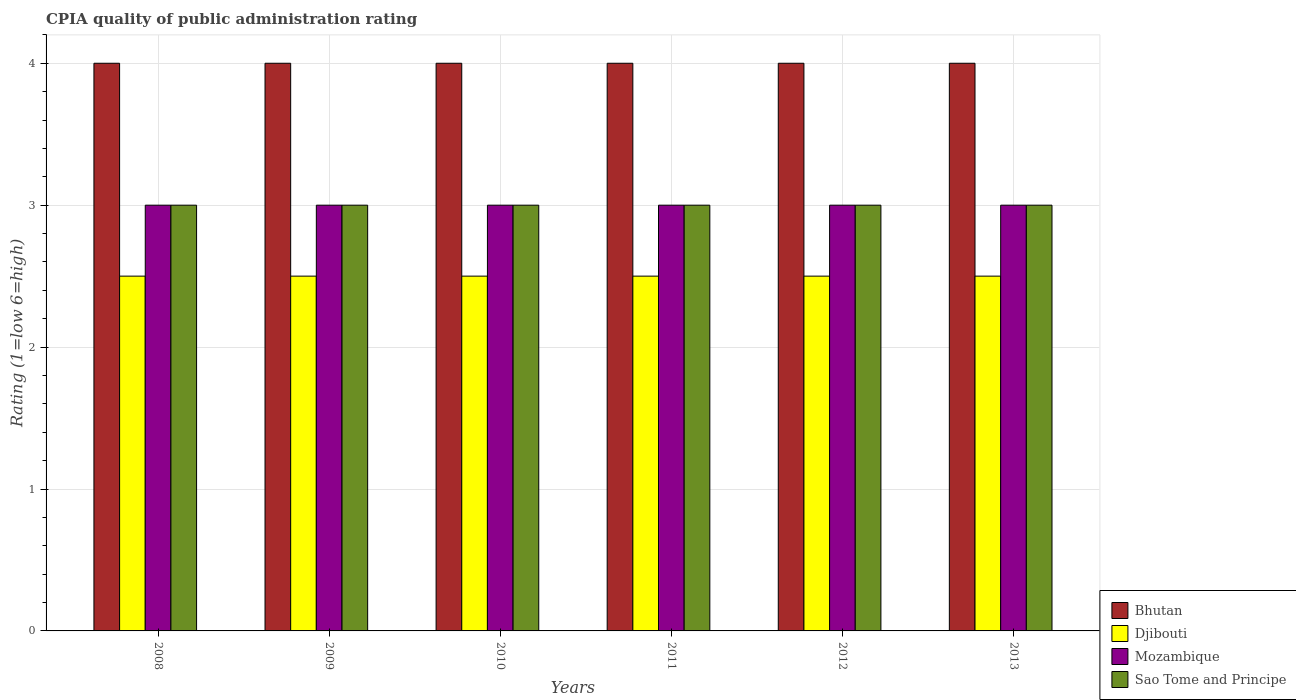How many different coloured bars are there?
Your answer should be compact. 4. How many bars are there on the 6th tick from the right?
Provide a short and direct response. 4. What is the label of the 4th group of bars from the left?
Ensure brevity in your answer.  2011. In how many cases, is the number of bars for a given year not equal to the number of legend labels?
Your answer should be compact. 0. Across all years, what is the maximum CPIA rating in Bhutan?
Give a very brief answer. 4. Across all years, what is the minimum CPIA rating in Mozambique?
Your answer should be compact. 3. What is the total CPIA rating in Bhutan in the graph?
Your response must be concise. 24. What is the difference between the CPIA rating in Bhutan in 2009 and that in 2011?
Ensure brevity in your answer.  0. What is the difference between the CPIA rating in Sao Tome and Principe in 2008 and the CPIA rating in Djibouti in 2013?
Your response must be concise. 0.5. Is the difference between the CPIA rating in Bhutan in 2008 and 2013 greater than the difference between the CPIA rating in Mozambique in 2008 and 2013?
Ensure brevity in your answer.  No. What is the difference between the highest and the lowest CPIA rating in Djibouti?
Provide a succinct answer. 0. In how many years, is the CPIA rating in Djibouti greater than the average CPIA rating in Djibouti taken over all years?
Offer a terse response. 0. What does the 4th bar from the left in 2013 represents?
Your answer should be compact. Sao Tome and Principe. What does the 2nd bar from the right in 2011 represents?
Ensure brevity in your answer.  Mozambique. Is it the case that in every year, the sum of the CPIA rating in Sao Tome and Principe and CPIA rating in Mozambique is greater than the CPIA rating in Djibouti?
Your answer should be compact. Yes. How many bars are there?
Your answer should be very brief. 24. Are all the bars in the graph horizontal?
Ensure brevity in your answer.  No. How many years are there in the graph?
Your answer should be compact. 6. What is the difference between two consecutive major ticks on the Y-axis?
Keep it short and to the point. 1. Are the values on the major ticks of Y-axis written in scientific E-notation?
Your response must be concise. No. Does the graph contain any zero values?
Make the answer very short. No. What is the title of the graph?
Give a very brief answer. CPIA quality of public administration rating. What is the label or title of the X-axis?
Provide a succinct answer. Years. What is the Rating (1=low 6=high) in Bhutan in 2008?
Your answer should be compact. 4. What is the Rating (1=low 6=high) in Djibouti in 2008?
Ensure brevity in your answer.  2.5. What is the Rating (1=low 6=high) of Sao Tome and Principe in 2008?
Provide a short and direct response. 3. What is the Rating (1=low 6=high) of Bhutan in 2009?
Provide a succinct answer. 4. What is the Rating (1=low 6=high) in Mozambique in 2009?
Provide a short and direct response. 3. What is the Rating (1=low 6=high) in Sao Tome and Principe in 2009?
Keep it short and to the point. 3. What is the Rating (1=low 6=high) of Sao Tome and Principe in 2010?
Your response must be concise. 3. What is the Rating (1=low 6=high) of Bhutan in 2011?
Give a very brief answer. 4. What is the Rating (1=low 6=high) of Mozambique in 2011?
Ensure brevity in your answer.  3. What is the Rating (1=low 6=high) in Sao Tome and Principe in 2011?
Give a very brief answer. 3. What is the Rating (1=low 6=high) in Sao Tome and Principe in 2012?
Ensure brevity in your answer.  3. What is the Rating (1=low 6=high) of Bhutan in 2013?
Your response must be concise. 4. What is the Rating (1=low 6=high) of Djibouti in 2013?
Give a very brief answer. 2.5. What is the Rating (1=low 6=high) of Mozambique in 2013?
Provide a short and direct response. 3. What is the Rating (1=low 6=high) of Sao Tome and Principe in 2013?
Your response must be concise. 3. Across all years, what is the maximum Rating (1=low 6=high) of Bhutan?
Offer a very short reply. 4. Across all years, what is the maximum Rating (1=low 6=high) in Sao Tome and Principe?
Ensure brevity in your answer.  3. Across all years, what is the minimum Rating (1=low 6=high) in Djibouti?
Make the answer very short. 2.5. Across all years, what is the minimum Rating (1=low 6=high) of Sao Tome and Principe?
Give a very brief answer. 3. What is the total Rating (1=low 6=high) in Bhutan in the graph?
Provide a short and direct response. 24. What is the total Rating (1=low 6=high) of Djibouti in the graph?
Provide a short and direct response. 15. What is the difference between the Rating (1=low 6=high) of Bhutan in 2008 and that in 2009?
Your answer should be compact. 0. What is the difference between the Rating (1=low 6=high) in Djibouti in 2008 and that in 2009?
Ensure brevity in your answer.  0. What is the difference between the Rating (1=low 6=high) of Mozambique in 2008 and that in 2009?
Offer a terse response. 0. What is the difference between the Rating (1=low 6=high) of Sao Tome and Principe in 2008 and that in 2010?
Give a very brief answer. 0. What is the difference between the Rating (1=low 6=high) of Sao Tome and Principe in 2008 and that in 2011?
Your response must be concise. 0. What is the difference between the Rating (1=low 6=high) in Djibouti in 2008 and that in 2012?
Offer a terse response. 0. What is the difference between the Rating (1=low 6=high) in Bhutan in 2008 and that in 2013?
Offer a terse response. 0. What is the difference between the Rating (1=low 6=high) of Djibouti in 2008 and that in 2013?
Provide a succinct answer. 0. What is the difference between the Rating (1=low 6=high) in Sao Tome and Principe in 2009 and that in 2010?
Keep it short and to the point. 0. What is the difference between the Rating (1=low 6=high) in Bhutan in 2009 and that in 2011?
Offer a very short reply. 0. What is the difference between the Rating (1=low 6=high) of Sao Tome and Principe in 2009 and that in 2011?
Your answer should be very brief. 0. What is the difference between the Rating (1=low 6=high) of Mozambique in 2009 and that in 2012?
Your response must be concise. 0. What is the difference between the Rating (1=low 6=high) in Sao Tome and Principe in 2009 and that in 2012?
Your answer should be very brief. 0. What is the difference between the Rating (1=low 6=high) of Bhutan in 2009 and that in 2013?
Your answer should be very brief. 0. What is the difference between the Rating (1=low 6=high) in Djibouti in 2009 and that in 2013?
Keep it short and to the point. 0. What is the difference between the Rating (1=low 6=high) of Mozambique in 2009 and that in 2013?
Offer a very short reply. 0. What is the difference between the Rating (1=low 6=high) in Sao Tome and Principe in 2009 and that in 2013?
Ensure brevity in your answer.  0. What is the difference between the Rating (1=low 6=high) of Bhutan in 2010 and that in 2011?
Keep it short and to the point. 0. What is the difference between the Rating (1=low 6=high) in Djibouti in 2010 and that in 2011?
Provide a succinct answer. 0. What is the difference between the Rating (1=low 6=high) of Mozambique in 2010 and that in 2011?
Provide a short and direct response. 0. What is the difference between the Rating (1=low 6=high) of Bhutan in 2010 and that in 2012?
Make the answer very short. 0. What is the difference between the Rating (1=low 6=high) of Djibouti in 2010 and that in 2012?
Make the answer very short. 0. What is the difference between the Rating (1=low 6=high) in Mozambique in 2010 and that in 2012?
Offer a terse response. 0. What is the difference between the Rating (1=low 6=high) of Sao Tome and Principe in 2010 and that in 2012?
Ensure brevity in your answer.  0. What is the difference between the Rating (1=low 6=high) in Mozambique in 2010 and that in 2013?
Give a very brief answer. 0. What is the difference between the Rating (1=low 6=high) in Djibouti in 2011 and that in 2012?
Make the answer very short. 0. What is the difference between the Rating (1=low 6=high) of Mozambique in 2011 and that in 2012?
Your answer should be compact. 0. What is the difference between the Rating (1=low 6=high) in Bhutan in 2011 and that in 2013?
Your answer should be compact. 0. What is the difference between the Rating (1=low 6=high) of Mozambique in 2011 and that in 2013?
Offer a very short reply. 0. What is the difference between the Rating (1=low 6=high) of Bhutan in 2012 and that in 2013?
Keep it short and to the point. 0. What is the difference between the Rating (1=low 6=high) of Djibouti in 2012 and that in 2013?
Your answer should be very brief. 0. What is the difference between the Rating (1=low 6=high) of Mozambique in 2012 and that in 2013?
Offer a very short reply. 0. What is the difference between the Rating (1=low 6=high) of Bhutan in 2008 and the Rating (1=low 6=high) of Djibouti in 2009?
Your answer should be compact. 1.5. What is the difference between the Rating (1=low 6=high) in Bhutan in 2008 and the Rating (1=low 6=high) in Mozambique in 2009?
Your response must be concise. 1. What is the difference between the Rating (1=low 6=high) in Bhutan in 2008 and the Rating (1=low 6=high) in Sao Tome and Principe in 2010?
Your response must be concise. 1. What is the difference between the Rating (1=low 6=high) of Bhutan in 2008 and the Rating (1=low 6=high) of Djibouti in 2011?
Provide a succinct answer. 1.5. What is the difference between the Rating (1=low 6=high) in Bhutan in 2008 and the Rating (1=low 6=high) in Sao Tome and Principe in 2011?
Provide a succinct answer. 1. What is the difference between the Rating (1=low 6=high) in Djibouti in 2008 and the Rating (1=low 6=high) in Mozambique in 2011?
Offer a terse response. -0.5. What is the difference between the Rating (1=low 6=high) in Djibouti in 2008 and the Rating (1=low 6=high) in Sao Tome and Principe in 2011?
Provide a succinct answer. -0.5. What is the difference between the Rating (1=low 6=high) in Bhutan in 2008 and the Rating (1=low 6=high) in Mozambique in 2012?
Your answer should be compact. 1. What is the difference between the Rating (1=low 6=high) of Bhutan in 2008 and the Rating (1=low 6=high) of Sao Tome and Principe in 2012?
Ensure brevity in your answer.  1. What is the difference between the Rating (1=low 6=high) in Djibouti in 2008 and the Rating (1=low 6=high) in Mozambique in 2012?
Provide a succinct answer. -0.5. What is the difference between the Rating (1=low 6=high) in Djibouti in 2008 and the Rating (1=low 6=high) in Sao Tome and Principe in 2012?
Offer a terse response. -0.5. What is the difference between the Rating (1=low 6=high) of Mozambique in 2008 and the Rating (1=low 6=high) of Sao Tome and Principe in 2012?
Offer a very short reply. 0. What is the difference between the Rating (1=low 6=high) of Bhutan in 2008 and the Rating (1=low 6=high) of Mozambique in 2013?
Offer a terse response. 1. What is the difference between the Rating (1=low 6=high) in Bhutan in 2008 and the Rating (1=low 6=high) in Sao Tome and Principe in 2013?
Offer a terse response. 1. What is the difference between the Rating (1=low 6=high) in Mozambique in 2008 and the Rating (1=low 6=high) in Sao Tome and Principe in 2013?
Give a very brief answer. 0. What is the difference between the Rating (1=low 6=high) in Djibouti in 2009 and the Rating (1=low 6=high) in Sao Tome and Principe in 2010?
Your response must be concise. -0.5. What is the difference between the Rating (1=low 6=high) of Mozambique in 2009 and the Rating (1=low 6=high) of Sao Tome and Principe in 2010?
Your response must be concise. 0. What is the difference between the Rating (1=low 6=high) in Bhutan in 2009 and the Rating (1=low 6=high) in Mozambique in 2011?
Offer a terse response. 1. What is the difference between the Rating (1=low 6=high) in Bhutan in 2009 and the Rating (1=low 6=high) in Sao Tome and Principe in 2011?
Provide a succinct answer. 1. What is the difference between the Rating (1=low 6=high) of Djibouti in 2009 and the Rating (1=low 6=high) of Sao Tome and Principe in 2011?
Offer a very short reply. -0.5. What is the difference between the Rating (1=low 6=high) in Mozambique in 2009 and the Rating (1=low 6=high) in Sao Tome and Principe in 2011?
Give a very brief answer. 0. What is the difference between the Rating (1=low 6=high) in Bhutan in 2009 and the Rating (1=low 6=high) in Djibouti in 2012?
Provide a short and direct response. 1.5. What is the difference between the Rating (1=low 6=high) in Bhutan in 2009 and the Rating (1=low 6=high) in Mozambique in 2012?
Provide a short and direct response. 1. What is the difference between the Rating (1=low 6=high) in Djibouti in 2009 and the Rating (1=low 6=high) in Mozambique in 2012?
Ensure brevity in your answer.  -0.5. What is the difference between the Rating (1=low 6=high) of Djibouti in 2009 and the Rating (1=low 6=high) of Sao Tome and Principe in 2012?
Offer a very short reply. -0.5. What is the difference between the Rating (1=low 6=high) of Mozambique in 2009 and the Rating (1=low 6=high) of Sao Tome and Principe in 2012?
Give a very brief answer. 0. What is the difference between the Rating (1=low 6=high) of Bhutan in 2009 and the Rating (1=low 6=high) of Djibouti in 2013?
Make the answer very short. 1.5. What is the difference between the Rating (1=low 6=high) of Bhutan in 2009 and the Rating (1=low 6=high) of Mozambique in 2013?
Give a very brief answer. 1. What is the difference between the Rating (1=low 6=high) of Bhutan in 2010 and the Rating (1=low 6=high) of Sao Tome and Principe in 2011?
Keep it short and to the point. 1. What is the difference between the Rating (1=low 6=high) in Djibouti in 2010 and the Rating (1=low 6=high) in Mozambique in 2011?
Keep it short and to the point. -0.5. What is the difference between the Rating (1=low 6=high) in Mozambique in 2010 and the Rating (1=low 6=high) in Sao Tome and Principe in 2011?
Provide a short and direct response. 0. What is the difference between the Rating (1=low 6=high) in Bhutan in 2010 and the Rating (1=low 6=high) in Djibouti in 2012?
Your answer should be compact. 1.5. What is the difference between the Rating (1=low 6=high) of Djibouti in 2010 and the Rating (1=low 6=high) of Mozambique in 2012?
Your answer should be compact. -0.5. What is the difference between the Rating (1=low 6=high) in Djibouti in 2010 and the Rating (1=low 6=high) in Sao Tome and Principe in 2012?
Provide a succinct answer. -0.5. What is the difference between the Rating (1=low 6=high) of Bhutan in 2010 and the Rating (1=low 6=high) of Djibouti in 2013?
Ensure brevity in your answer.  1.5. What is the difference between the Rating (1=low 6=high) of Bhutan in 2010 and the Rating (1=low 6=high) of Mozambique in 2013?
Offer a terse response. 1. What is the difference between the Rating (1=low 6=high) of Djibouti in 2010 and the Rating (1=low 6=high) of Sao Tome and Principe in 2013?
Your response must be concise. -0.5. What is the difference between the Rating (1=low 6=high) of Mozambique in 2011 and the Rating (1=low 6=high) of Sao Tome and Principe in 2012?
Ensure brevity in your answer.  0. What is the difference between the Rating (1=low 6=high) in Bhutan in 2011 and the Rating (1=low 6=high) in Djibouti in 2013?
Offer a very short reply. 1.5. What is the difference between the Rating (1=low 6=high) of Bhutan in 2011 and the Rating (1=low 6=high) of Mozambique in 2013?
Your answer should be compact. 1. What is the difference between the Rating (1=low 6=high) in Bhutan in 2011 and the Rating (1=low 6=high) in Sao Tome and Principe in 2013?
Offer a very short reply. 1. What is the difference between the Rating (1=low 6=high) in Djibouti in 2011 and the Rating (1=low 6=high) in Sao Tome and Principe in 2013?
Your answer should be very brief. -0.5. What is the difference between the Rating (1=low 6=high) in Bhutan in 2012 and the Rating (1=low 6=high) in Sao Tome and Principe in 2013?
Make the answer very short. 1. What is the difference between the Rating (1=low 6=high) of Djibouti in 2012 and the Rating (1=low 6=high) of Mozambique in 2013?
Make the answer very short. -0.5. What is the average Rating (1=low 6=high) in Sao Tome and Principe per year?
Your answer should be compact. 3. In the year 2008, what is the difference between the Rating (1=low 6=high) of Bhutan and Rating (1=low 6=high) of Djibouti?
Offer a very short reply. 1.5. In the year 2008, what is the difference between the Rating (1=low 6=high) of Bhutan and Rating (1=low 6=high) of Mozambique?
Give a very brief answer. 1. In the year 2008, what is the difference between the Rating (1=low 6=high) in Bhutan and Rating (1=low 6=high) in Sao Tome and Principe?
Your response must be concise. 1. In the year 2008, what is the difference between the Rating (1=low 6=high) in Djibouti and Rating (1=low 6=high) in Mozambique?
Your answer should be very brief. -0.5. In the year 2008, what is the difference between the Rating (1=low 6=high) of Djibouti and Rating (1=low 6=high) of Sao Tome and Principe?
Offer a very short reply. -0.5. In the year 2009, what is the difference between the Rating (1=low 6=high) of Bhutan and Rating (1=low 6=high) of Djibouti?
Provide a short and direct response. 1.5. In the year 2009, what is the difference between the Rating (1=low 6=high) of Bhutan and Rating (1=low 6=high) of Mozambique?
Provide a short and direct response. 1. In the year 2010, what is the difference between the Rating (1=low 6=high) of Bhutan and Rating (1=low 6=high) of Djibouti?
Provide a short and direct response. 1.5. In the year 2010, what is the difference between the Rating (1=low 6=high) in Bhutan and Rating (1=low 6=high) in Mozambique?
Provide a succinct answer. 1. In the year 2010, what is the difference between the Rating (1=low 6=high) of Bhutan and Rating (1=low 6=high) of Sao Tome and Principe?
Make the answer very short. 1. In the year 2010, what is the difference between the Rating (1=low 6=high) of Djibouti and Rating (1=low 6=high) of Mozambique?
Ensure brevity in your answer.  -0.5. In the year 2010, what is the difference between the Rating (1=low 6=high) of Djibouti and Rating (1=low 6=high) of Sao Tome and Principe?
Provide a short and direct response. -0.5. In the year 2011, what is the difference between the Rating (1=low 6=high) of Bhutan and Rating (1=low 6=high) of Djibouti?
Offer a very short reply. 1.5. In the year 2011, what is the difference between the Rating (1=low 6=high) of Bhutan and Rating (1=low 6=high) of Mozambique?
Keep it short and to the point. 1. In the year 2011, what is the difference between the Rating (1=low 6=high) of Djibouti and Rating (1=low 6=high) of Mozambique?
Your answer should be very brief. -0.5. In the year 2011, what is the difference between the Rating (1=low 6=high) of Mozambique and Rating (1=low 6=high) of Sao Tome and Principe?
Give a very brief answer. 0. In the year 2012, what is the difference between the Rating (1=low 6=high) of Bhutan and Rating (1=low 6=high) of Djibouti?
Your answer should be very brief. 1.5. In the year 2012, what is the difference between the Rating (1=low 6=high) of Bhutan and Rating (1=low 6=high) of Mozambique?
Keep it short and to the point. 1. In the year 2012, what is the difference between the Rating (1=low 6=high) of Bhutan and Rating (1=low 6=high) of Sao Tome and Principe?
Your response must be concise. 1. In the year 2012, what is the difference between the Rating (1=low 6=high) in Djibouti and Rating (1=low 6=high) in Mozambique?
Provide a succinct answer. -0.5. In the year 2012, what is the difference between the Rating (1=low 6=high) in Mozambique and Rating (1=low 6=high) in Sao Tome and Principe?
Keep it short and to the point. 0. In the year 2013, what is the difference between the Rating (1=low 6=high) of Bhutan and Rating (1=low 6=high) of Djibouti?
Offer a terse response. 1.5. In the year 2013, what is the difference between the Rating (1=low 6=high) in Bhutan and Rating (1=low 6=high) in Mozambique?
Your answer should be very brief. 1. In the year 2013, what is the difference between the Rating (1=low 6=high) in Bhutan and Rating (1=low 6=high) in Sao Tome and Principe?
Keep it short and to the point. 1. In the year 2013, what is the difference between the Rating (1=low 6=high) in Mozambique and Rating (1=low 6=high) in Sao Tome and Principe?
Your response must be concise. 0. What is the ratio of the Rating (1=low 6=high) of Bhutan in 2008 to that in 2010?
Your response must be concise. 1. What is the ratio of the Rating (1=low 6=high) in Djibouti in 2008 to that in 2010?
Your answer should be compact. 1. What is the ratio of the Rating (1=low 6=high) in Mozambique in 2008 to that in 2010?
Provide a succinct answer. 1. What is the ratio of the Rating (1=low 6=high) of Sao Tome and Principe in 2008 to that in 2010?
Your answer should be very brief. 1. What is the ratio of the Rating (1=low 6=high) in Mozambique in 2008 to that in 2011?
Offer a very short reply. 1. What is the ratio of the Rating (1=low 6=high) of Sao Tome and Principe in 2008 to that in 2011?
Your answer should be very brief. 1. What is the ratio of the Rating (1=low 6=high) of Bhutan in 2008 to that in 2012?
Provide a short and direct response. 1. What is the ratio of the Rating (1=low 6=high) of Mozambique in 2008 to that in 2012?
Offer a very short reply. 1. What is the ratio of the Rating (1=low 6=high) in Bhutan in 2009 to that in 2010?
Offer a terse response. 1. What is the ratio of the Rating (1=low 6=high) in Mozambique in 2009 to that in 2010?
Give a very brief answer. 1. What is the ratio of the Rating (1=low 6=high) of Sao Tome and Principe in 2009 to that in 2010?
Your answer should be compact. 1. What is the ratio of the Rating (1=low 6=high) of Bhutan in 2009 to that in 2011?
Make the answer very short. 1. What is the ratio of the Rating (1=low 6=high) of Djibouti in 2009 to that in 2011?
Give a very brief answer. 1. What is the ratio of the Rating (1=low 6=high) of Sao Tome and Principe in 2009 to that in 2011?
Your answer should be very brief. 1. What is the ratio of the Rating (1=low 6=high) of Djibouti in 2009 to that in 2012?
Provide a succinct answer. 1. What is the ratio of the Rating (1=low 6=high) in Sao Tome and Principe in 2009 to that in 2012?
Offer a terse response. 1. What is the ratio of the Rating (1=low 6=high) of Bhutan in 2009 to that in 2013?
Ensure brevity in your answer.  1. What is the ratio of the Rating (1=low 6=high) of Bhutan in 2010 to that in 2012?
Ensure brevity in your answer.  1. What is the ratio of the Rating (1=low 6=high) in Sao Tome and Principe in 2010 to that in 2012?
Your response must be concise. 1. What is the ratio of the Rating (1=low 6=high) in Mozambique in 2010 to that in 2013?
Offer a terse response. 1. What is the ratio of the Rating (1=low 6=high) in Bhutan in 2011 to that in 2012?
Make the answer very short. 1. What is the ratio of the Rating (1=low 6=high) of Mozambique in 2011 to that in 2012?
Your response must be concise. 1. What is the ratio of the Rating (1=low 6=high) of Mozambique in 2011 to that in 2013?
Offer a terse response. 1. What is the ratio of the Rating (1=low 6=high) in Djibouti in 2012 to that in 2013?
Make the answer very short. 1. What is the ratio of the Rating (1=low 6=high) of Mozambique in 2012 to that in 2013?
Give a very brief answer. 1. What is the difference between the highest and the second highest Rating (1=low 6=high) of Djibouti?
Your response must be concise. 0. What is the difference between the highest and the second highest Rating (1=low 6=high) in Sao Tome and Principe?
Provide a succinct answer. 0. What is the difference between the highest and the lowest Rating (1=low 6=high) of Mozambique?
Make the answer very short. 0. 